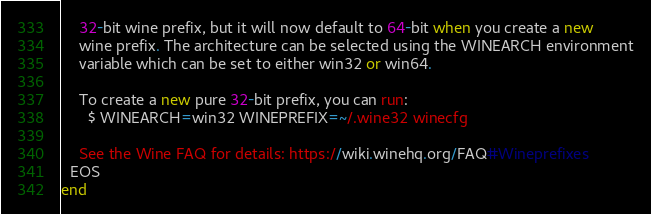Convert code to text. <code><loc_0><loc_0><loc_500><loc_500><_Ruby_>    32-bit wine prefix, but it will now default to 64-bit when you create a new
    wine prefix. The architecture can be selected using the WINEARCH environment
    variable which can be set to either win32 or win64.

    To create a new pure 32-bit prefix, you can run:
      $ WINEARCH=win32 WINEPREFIX=~/.wine32 winecfg

    See the Wine FAQ for details: https://wiki.winehq.org/FAQ#Wineprefixes
  EOS
end
</code> 